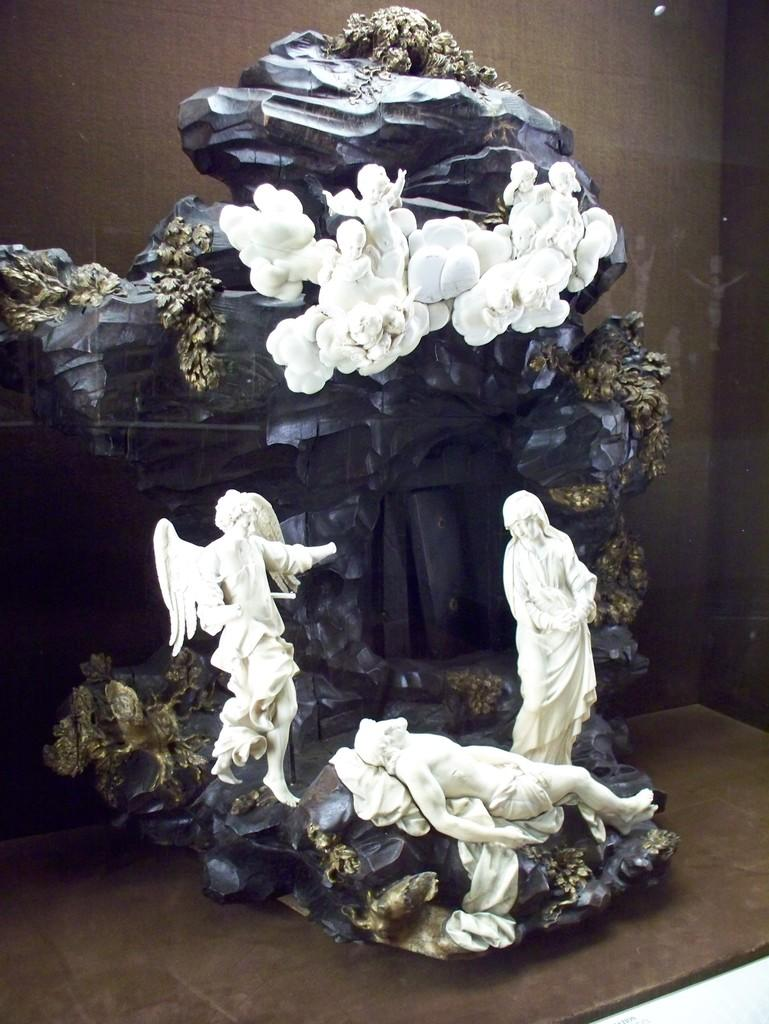What is the main subject of the image? There is a sculpture in the image. What is the sculpture placed on? The sculpture is on a wooden surface. What materials are used in the sculpture? The sculpture contains rocks. Are there any people depicted in the sculpture? Yes, there are people on the rocks in the sculpture. What type of store is featured in the image? There is no store present in the image; it features a sculpture with rocks and people. Is the queen present in the image? There is no reference to a queen or any royal figure in the image. 